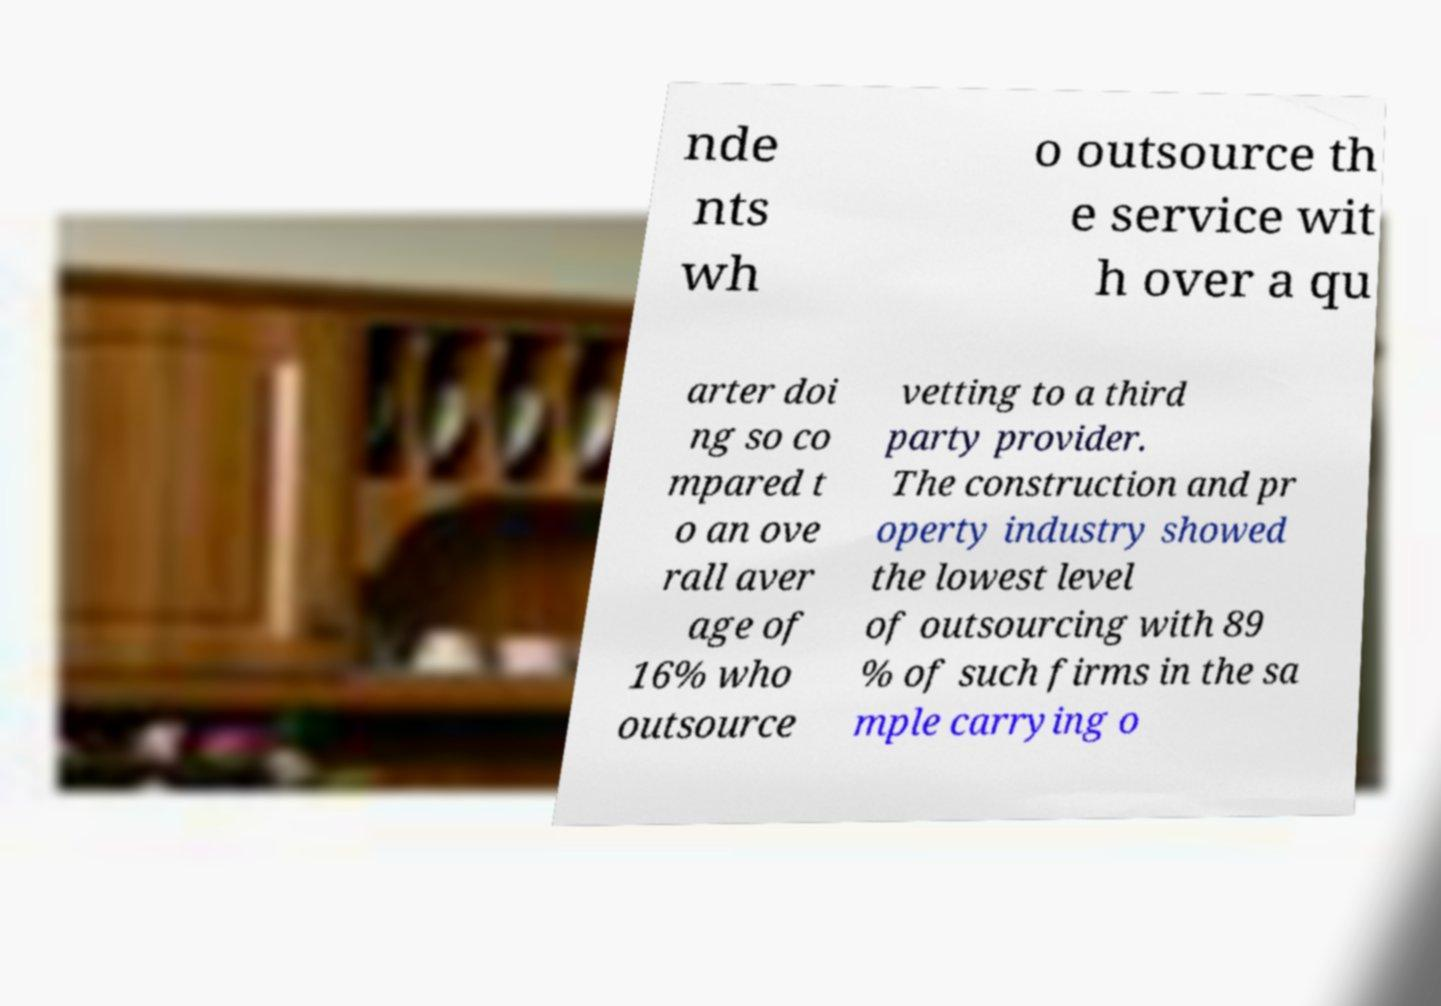There's text embedded in this image that I need extracted. Can you transcribe it verbatim? nde nts wh o outsource th e service wit h over a qu arter doi ng so co mpared t o an ove rall aver age of 16% who outsource vetting to a third party provider. The construction and pr operty industry showed the lowest level of outsourcing with 89 % of such firms in the sa mple carrying o 